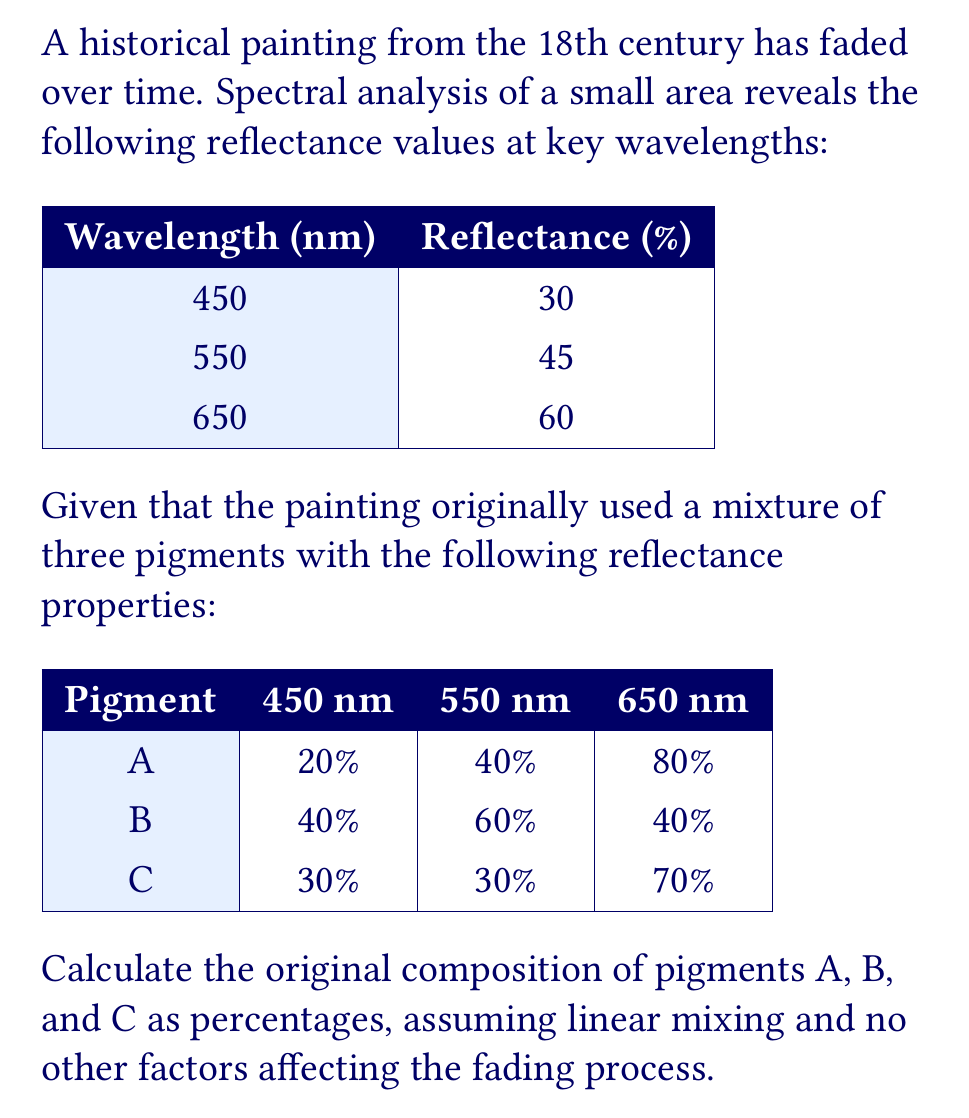Can you solve this math problem? To solve this inverse problem, we'll use a system of linear equations based on the reflectance values at each wavelength. Let $x$, $y$, and $z$ represent the percentages of pigments A, B, and C, respectively.

1) Set up the system of equations:
   $$
   \begin{cases}
   0.20x + 0.40y + 0.30z = 0.30 \quad \text{(450 nm)} \\
   0.40x + 0.60y + 0.30z = 0.45 \quad \text{(550 nm)} \\
   0.80x + 0.40y + 0.70z = 0.60 \quad \text{(650 nm)} \\
   x + y + z = 1 \quad \text{(sum of percentages)}
   \end{cases}
   $$

2) Solve the system using substitution or matrix methods. Here, we'll use matrix notation:
   $$
   \begin{bmatrix}
   0.20 & 0.40 & 0.30 & 0.30 \\
   0.40 & 0.60 & 0.30 & 0.45 \\
   0.80 & 0.40 & 0.70 & 0.60 \\
   1 & 1 & 1 & 1
   \end{bmatrix}
   $$

3) Using Gaussian elimination or a calculator, we find:
   $$
   x \approx 0.4286 \quad y \approx 0.2857 \quad z \approx 0.2857
   $$

4) Convert to percentages:
   Pigment A: $0.4286 \times 100\% \approx 42.86\%$
   Pigment B: $0.2857 \times 100\% \approx 28.57\%$
   Pigment C: $0.2857 \times 100\% \approx 28.57\%$

5) Verify that the percentages sum to 100%:
   $42.86\% + 28.57\% + 28.57\% = 100\%$
Answer: Pigment A: 42.86%, Pigment B: 28.57%, Pigment C: 28.57% 